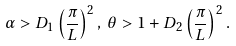Convert formula to latex. <formula><loc_0><loc_0><loc_500><loc_500>\alpha > D _ { 1 } \left ( \frac { \pi } { L } \right ) ^ { 2 } , \, \theta > 1 + D _ { 2 } \left ( \frac { \pi } { L } \right ) ^ { 2 } .</formula> 